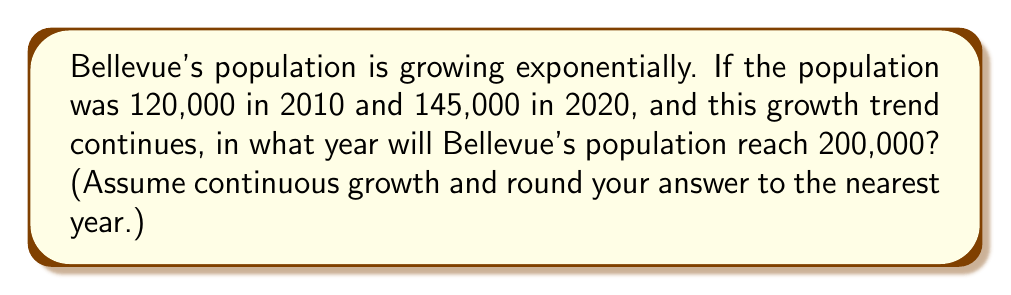Help me with this question. Let's approach this step-by-step:

1) We can model this with the exponential function $P(t) = P_0e^{rt}$, where:
   $P(t)$ is the population at time $t$
   $P_0$ is the initial population
   $r$ is the growth rate
   $t$ is the time in years

2) We know two points: 
   $(0, 120000)$ for 2010
   $(10, 145000)$ for 2020

3) Let's find $r$ using these points:

   $145000 = 120000e^{10r}$

4) Dividing both sides by 120000:

   $\frac{145000}{120000} = e^{10r}$

5) Taking natural log of both sides:

   $\ln(\frac{145000}{120000}) = 10r$

6) Solving for $r$:

   $r = \frac{\ln(\frac{145000}{120000})}{10} \approx 0.0190$ or about 1.90% per year

7) Now, we want to find when the population will reach 200,000. We can set up the equation:

   $200000 = 120000e^{rt}$

8) Dividing both sides by 120000:

   $\frac{200000}{120000} = e^{rt}$

9) Taking natural log of both sides:

   $\ln(\frac{200000}{120000}) = rt$

10) Solving for $t$:

    $t = \frac{\ln(\frac{200000}{120000})}{r} = \frac{\ln(\frac{200000}{120000})}{\frac{\ln(\frac{145000}{120000})}{10}} \approx 26.37$ years

11) Since we started at 2010, we add 26.37 to 2010:

    2010 + 26.37 = 2036.37

12) Rounding to the nearest year, we get 2036.
Answer: 2036 